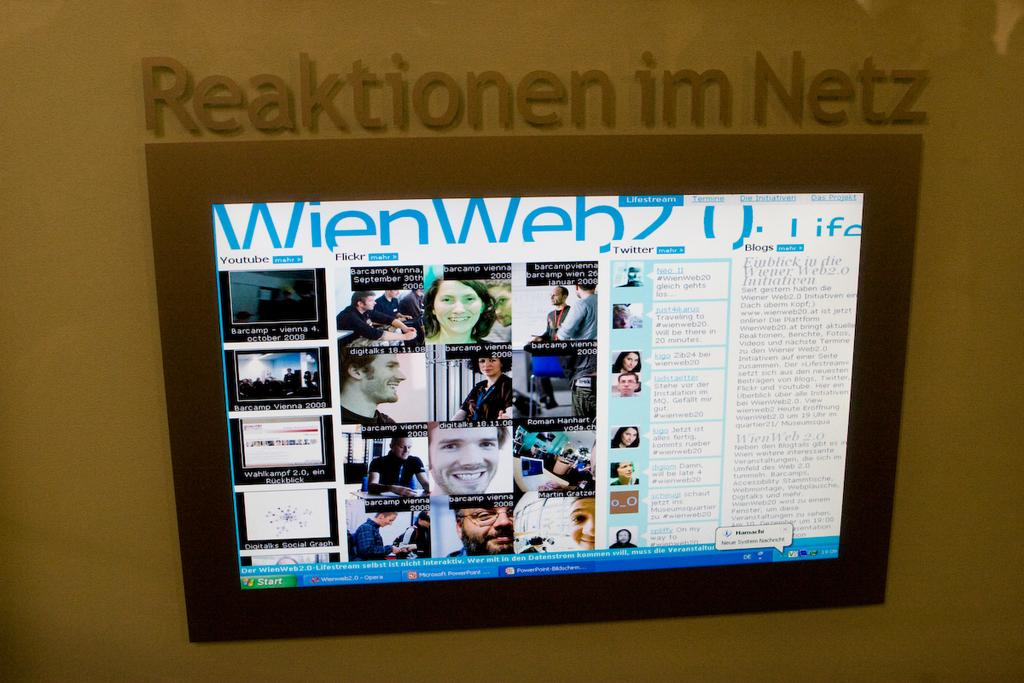<image>
Create a compact narrative representing the image presented. A screen is mounted on a wall under the words "Reaktionen im Netz." 